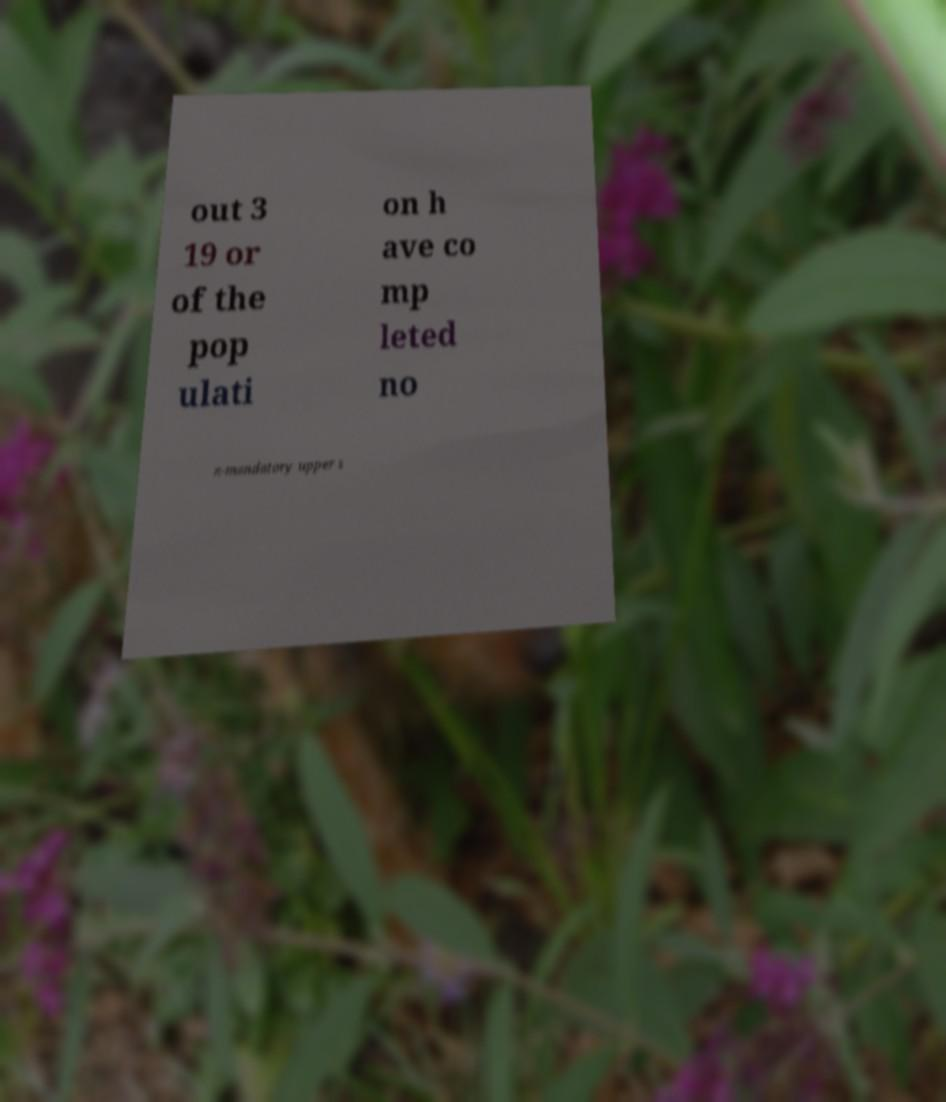Can you accurately transcribe the text from the provided image for me? out 3 19 or of the pop ulati on h ave co mp leted no n-mandatory upper s 